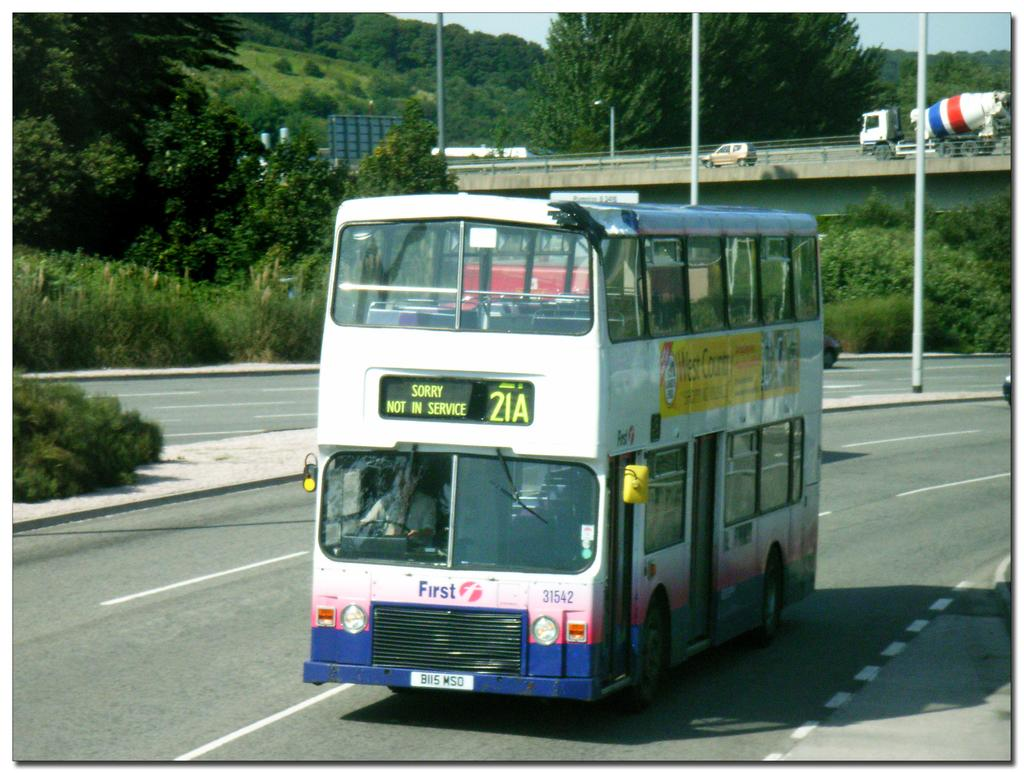<image>
Describe the image concisely. A large white bus that says sorry not in service, 21A on the ticker. 